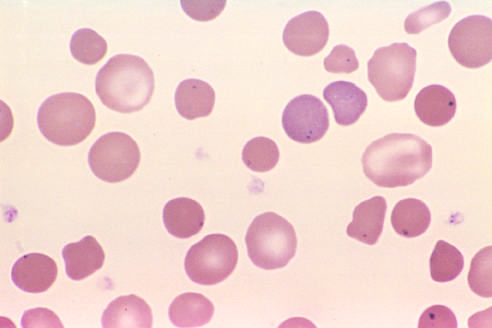re cystic hygromas present in the red cells of this asplenic patient?
Answer the question using a single word or phrase. No 